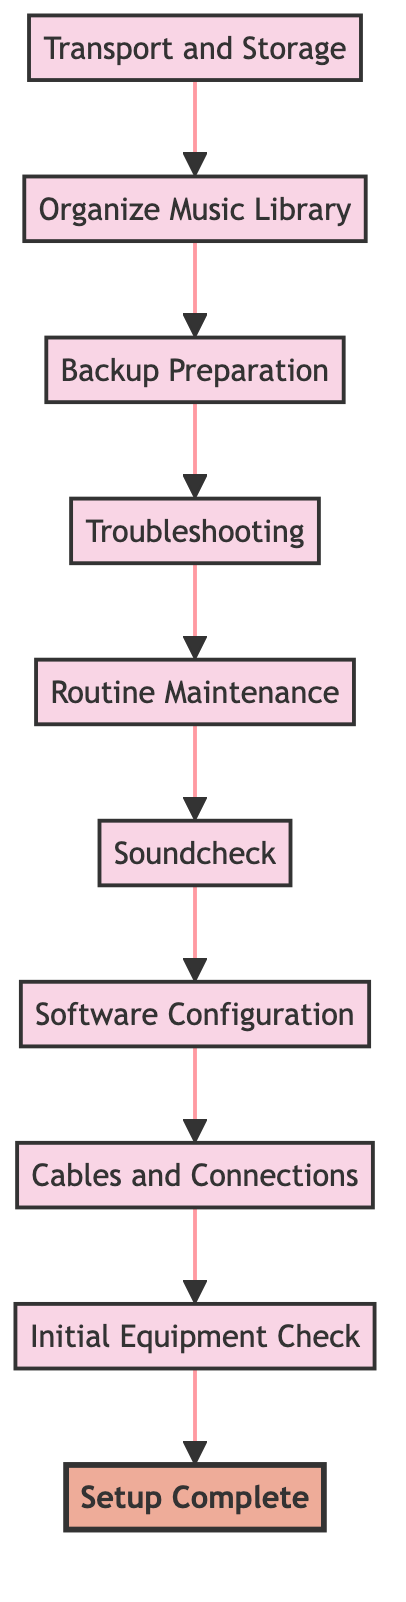What is the starting point of the flow? The starting point of the flow is "Transport and Storage," which is the first node at the bottom of the diagram. It indicates where the process begins.
Answer: Transport and Storage What is the final step in the flow? The final step in the flow is "Setup Complete," which is the last node at the top of the diagram. It signifies the completion of all necessary setup activities.
Answer: Setup Complete How many steps are in the process? The process consists of 10 steps/nodes, which are listed from "Transport and Storage" to "Setup Complete." Counting each step gives us this total.
Answer: 10 What comes immediately before "Troubleshooting"? The step that comes immediately before "Troubleshooting" is "Backup Preparation," which is the node that leads into the troubleshooting phase.
Answer: Backup Preparation Which step involves organizing music? The step that involves organizing music is "Organize Music Library," which is focused on arranging the digital music collection for DJing.
Answer: Organize Music Library What are two steps connected directly to "Routine Maintenance"? "Routine Maintenance" is connected directly to "Troubleshooting," and also flows into "Soundcheck," representing the maintenance followed by audio testing.
Answer: Troubleshooting, Soundcheck How does "Cables and Connections" relate to "Initial Equipment Check"? "Cables and Connections" is the step that follows "Initial Equipment Check," indicating that after checking the equipment, one should ensure all connections are secure.
Answer: It follows it What is the relationship between "Software Configuration" and "Soundcheck"? "Software Configuration" precedes "Soundcheck," meaning that the software must be configured before testing the audio output, allowing for a proper soundcheck.
Answer: "Software Configuration" precedes it Which two nodes are the furthest apart in the flow? "Transport and Storage" and "Setup Complete" are the furthest apart since they are at the opposite ends of the flowchart, representing the beginning and end of the setup process.
Answer: Transport and Storage, Setup Complete What action should be performed before soundchecking? Before performing a soundcheck, the action to be completed is "Software Configuration," which is necessary to ensure the software is set up for audio output testing.
Answer: Software Configuration 